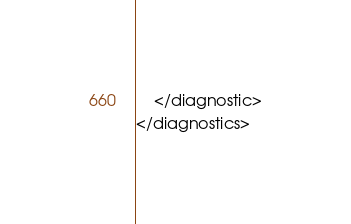Convert code to text. <code><loc_0><loc_0><loc_500><loc_500><_XML_>	</diagnostic>
</diagnostics>
</code> 